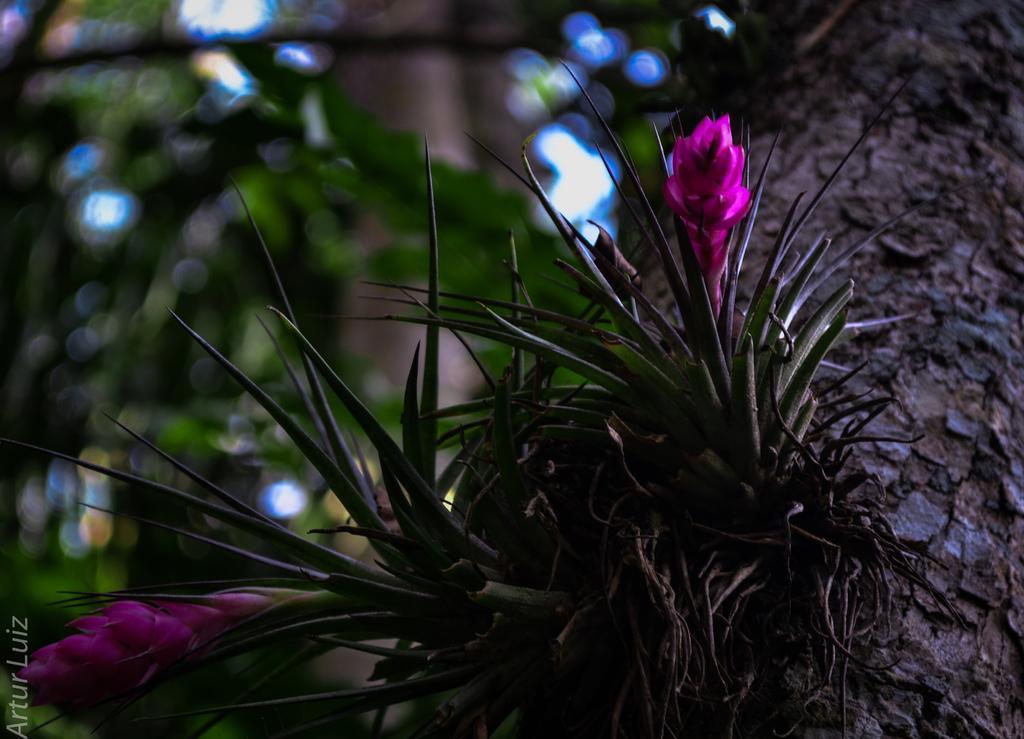Could you give a brief overview of what you see in this image? In this picture we can see plants, flowers, tree trunk and in the background we can see trees and it is blurry. 